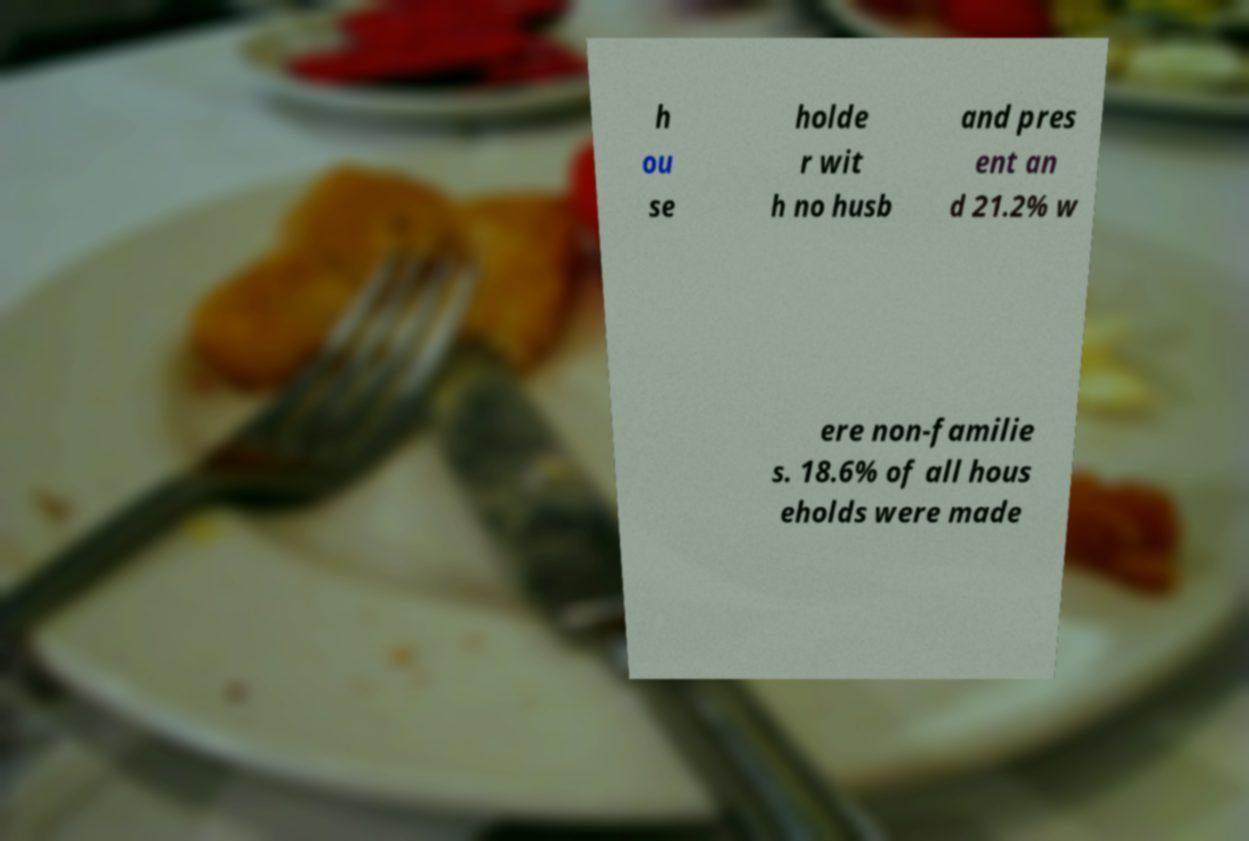Please identify and transcribe the text found in this image. h ou se holde r wit h no husb and pres ent an d 21.2% w ere non-familie s. 18.6% of all hous eholds were made 